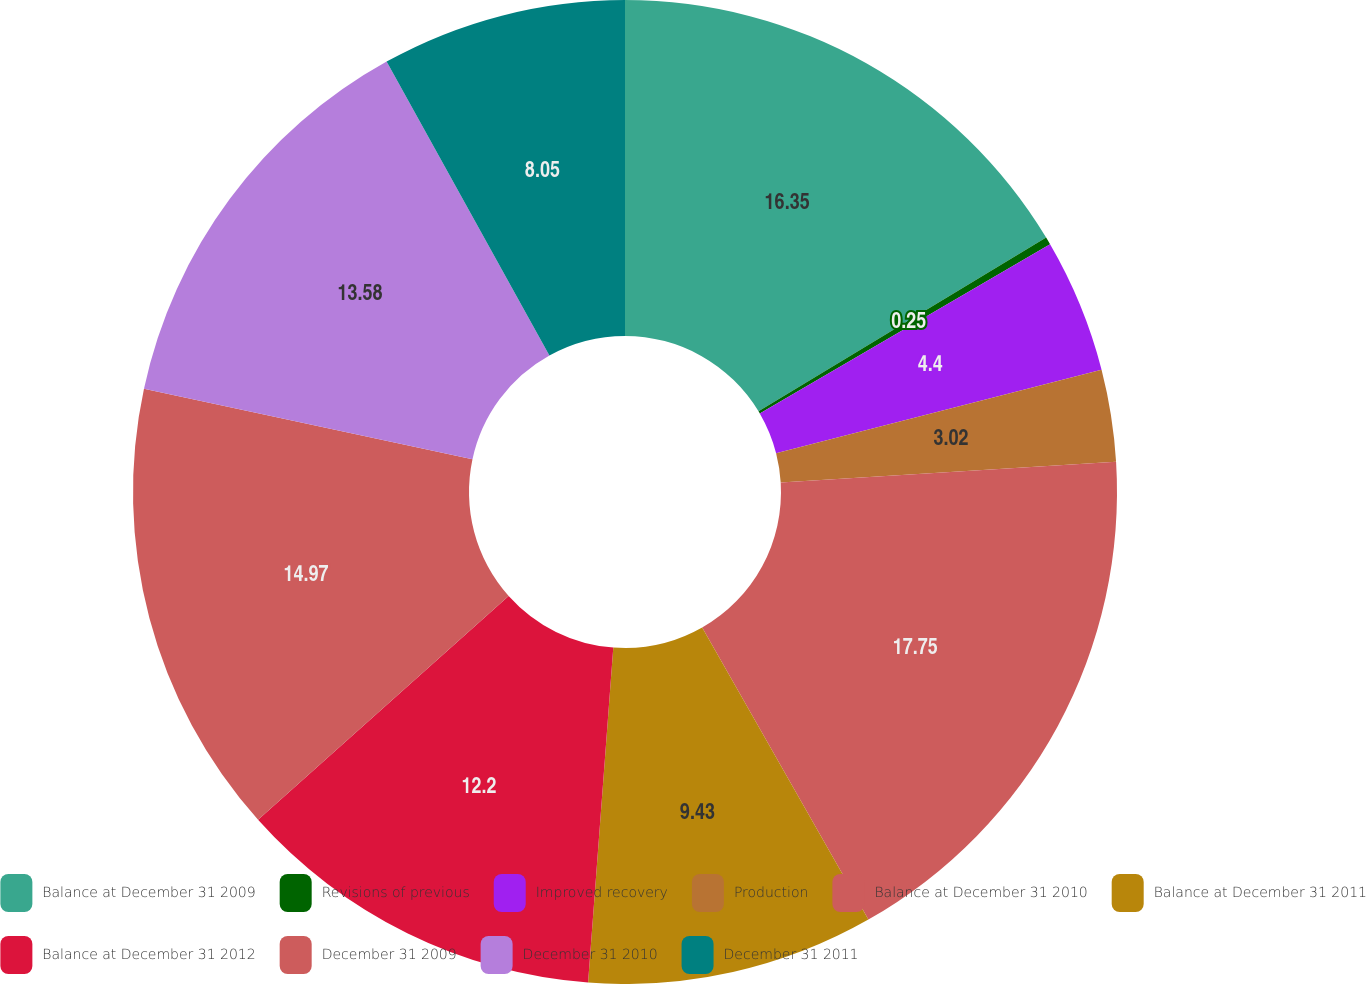Convert chart. <chart><loc_0><loc_0><loc_500><loc_500><pie_chart><fcel>Balance at December 31 2009<fcel>Revisions of previous<fcel>Improved recovery<fcel>Production<fcel>Balance at December 31 2010<fcel>Balance at December 31 2011<fcel>Balance at December 31 2012<fcel>December 31 2009<fcel>December 31 2010<fcel>December 31 2011<nl><fcel>16.35%<fcel>0.25%<fcel>4.4%<fcel>3.02%<fcel>17.74%<fcel>9.43%<fcel>12.2%<fcel>14.97%<fcel>13.58%<fcel>8.05%<nl></chart> 